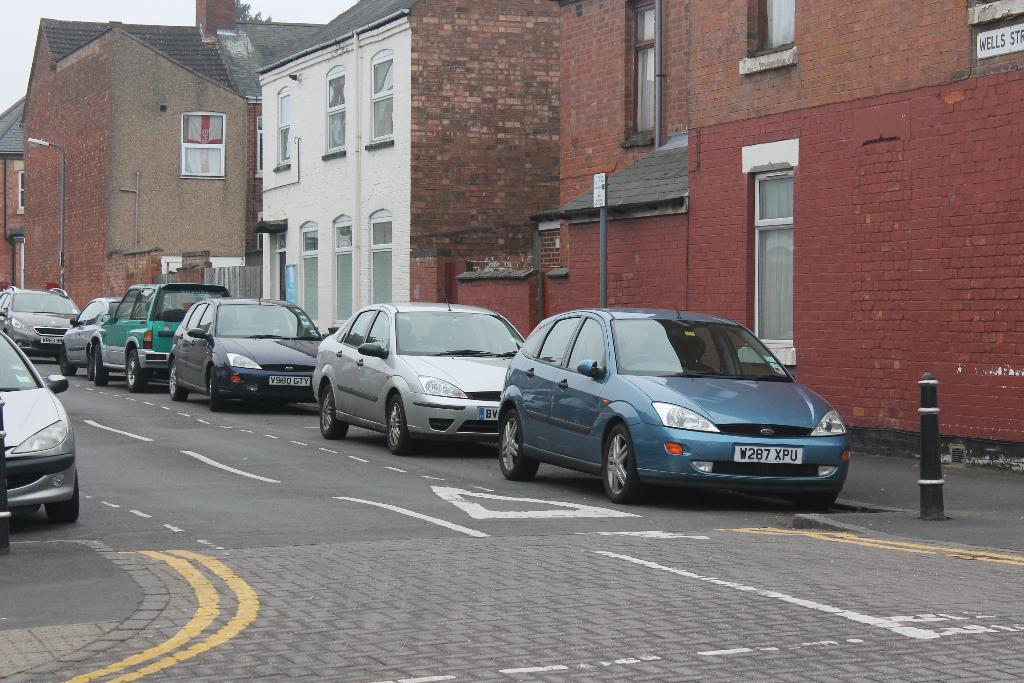What type of structure is present in the image? There is a building in the image. What can be seen on the road in front of the building? Vehicles are parked on the road in front of the building. What objects are visible in front of the building? There are poles visible in front of the building. What part of the natural environment is visible in the image? The sky is visible in the top left corner of the image. What type of chin can be seen on the mountain in the image? There is no mountain or chin present in the image. How many tickets are visible in the image? There are no tickets present in the image. 